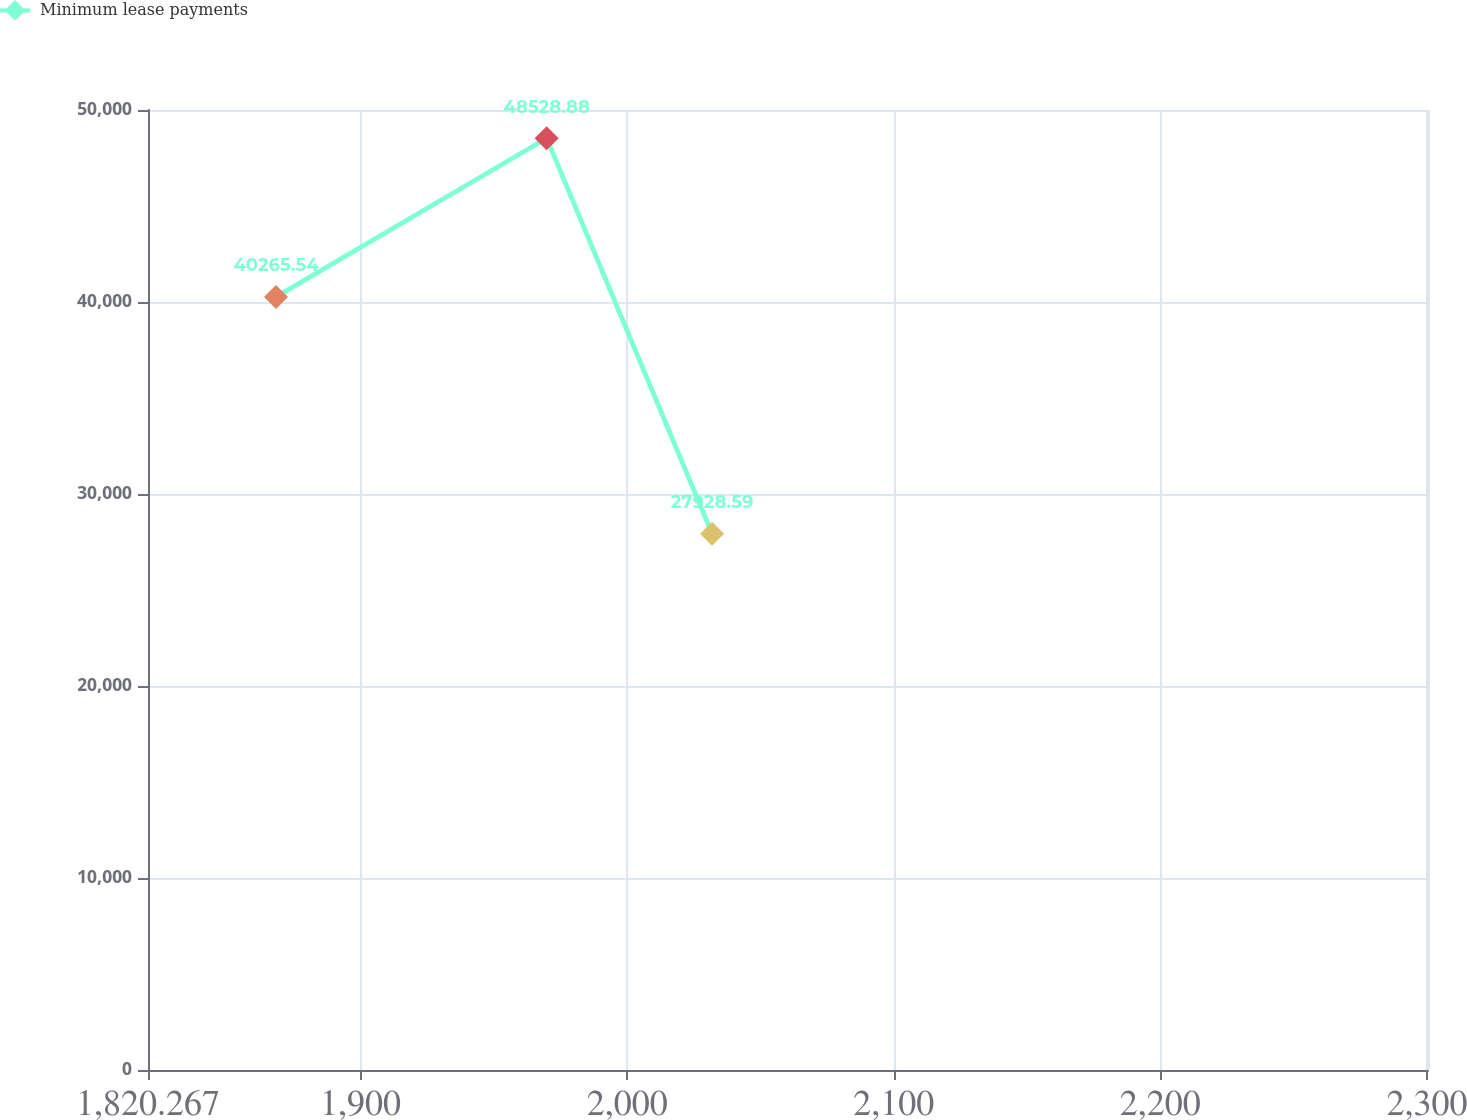Convert chart. <chart><loc_0><loc_0><loc_500><loc_500><line_chart><ecel><fcel>Minimum lease payments<nl><fcel>1868.28<fcel>40265.5<nl><fcel>1969.8<fcel>48528.9<nl><fcel>2031.86<fcel>27928.6<nl><fcel>2300.46<fcel>24188.1<nl><fcel>2348.41<fcel>11124.1<nl></chart> 